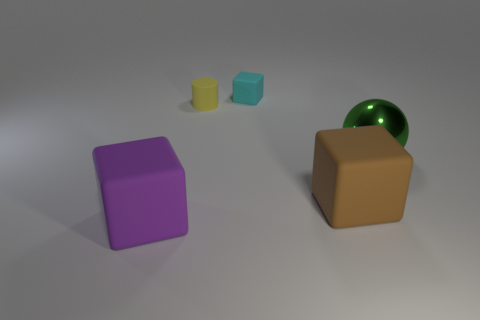Add 4 big shiny cubes. How many objects exist? 9 Subtract all cylinders. How many objects are left? 4 Subtract 0 blue cylinders. How many objects are left? 5 Subtract all brown rubber cubes. Subtract all small yellow cylinders. How many objects are left? 3 Add 5 brown things. How many brown things are left? 6 Add 2 purple rubber spheres. How many purple rubber spheres exist? 2 